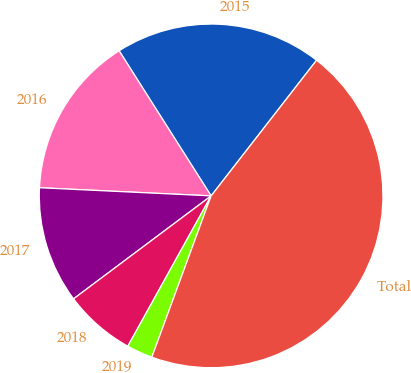Convert chart to OTSL. <chart><loc_0><loc_0><loc_500><loc_500><pie_chart><fcel>2015<fcel>2016<fcel>2017<fcel>2018<fcel>2019<fcel>Total<nl><fcel>19.51%<fcel>15.25%<fcel>10.98%<fcel>6.72%<fcel>2.45%<fcel>45.09%<nl></chart> 